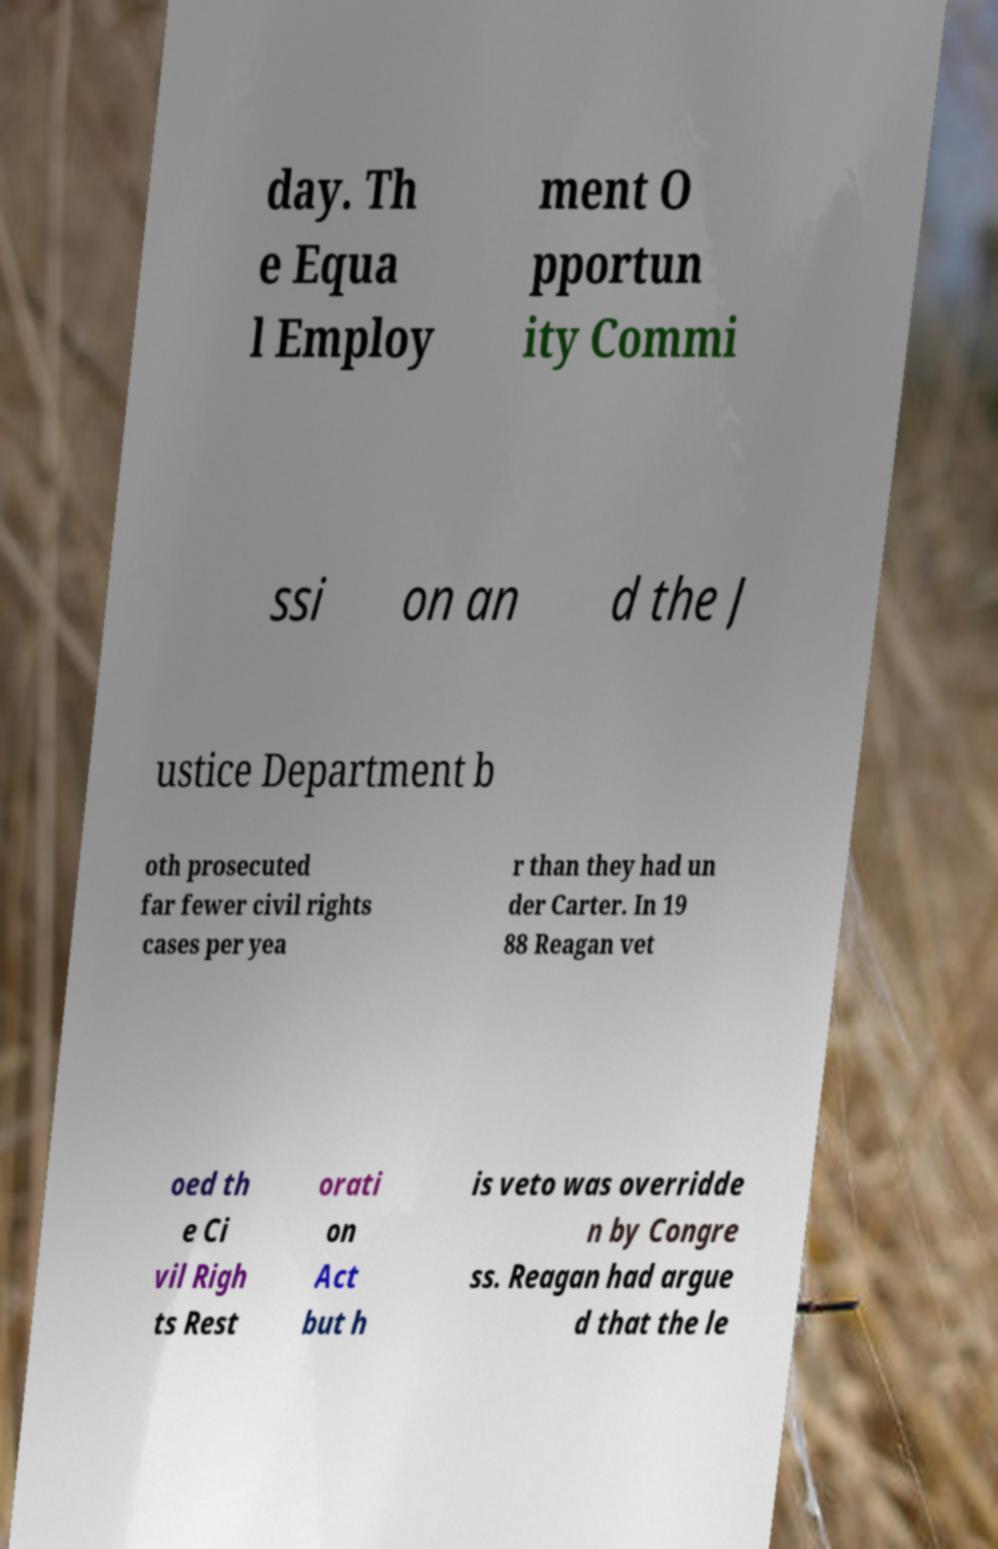Can you accurately transcribe the text from the provided image for me? day. Th e Equa l Employ ment O pportun ity Commi ssi on an d the J ustice Department b oth prosecuted far fewer civil rights cases per yea r than they had un der Carter. In 19 88 Reagan vet oed th e Ci vil Righ ts Rest orati on Act but h is veto was overridde n by Congre ss. Reagan had argue d that the le 